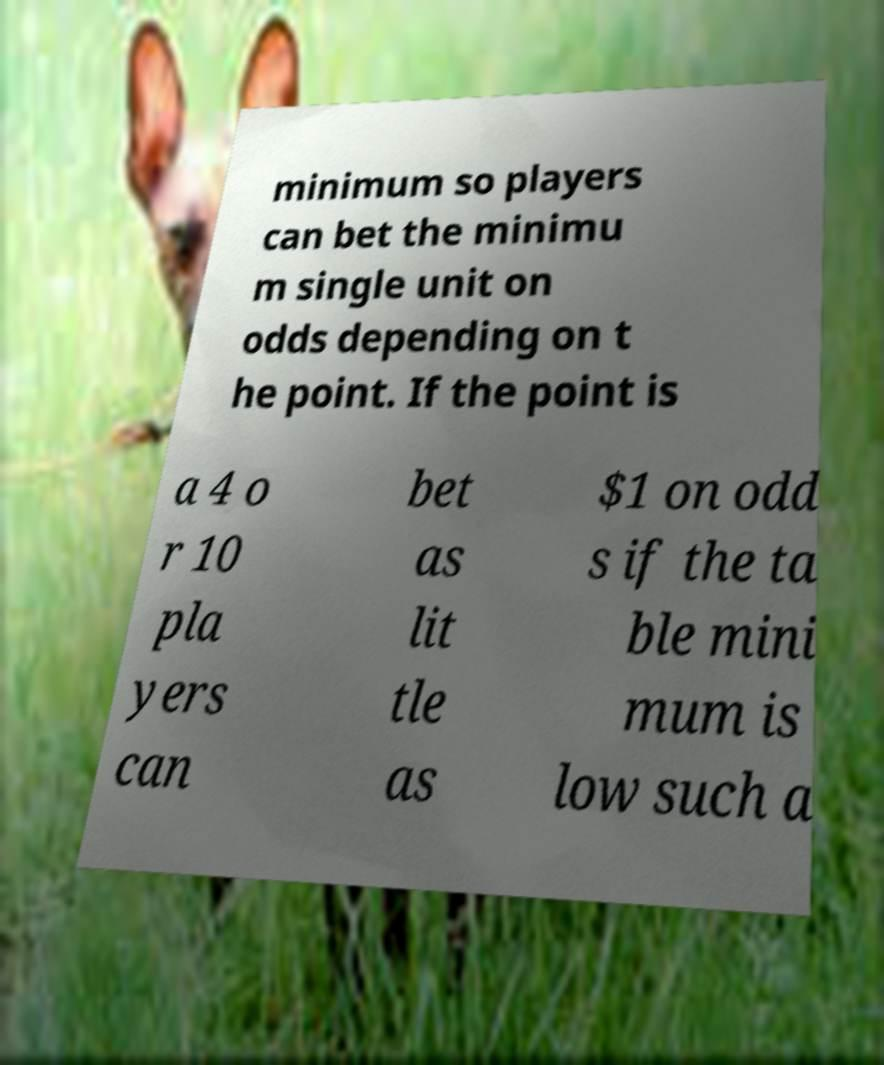I need the written content from this picture converted into text. Can you do that? minimum so players can bet the minimu m single unit on odds depending on t he point. If the point is a 4 o r 10 pla yers can bet as lit tle as $1 on odd s if the ta ble mini mum is low such a 